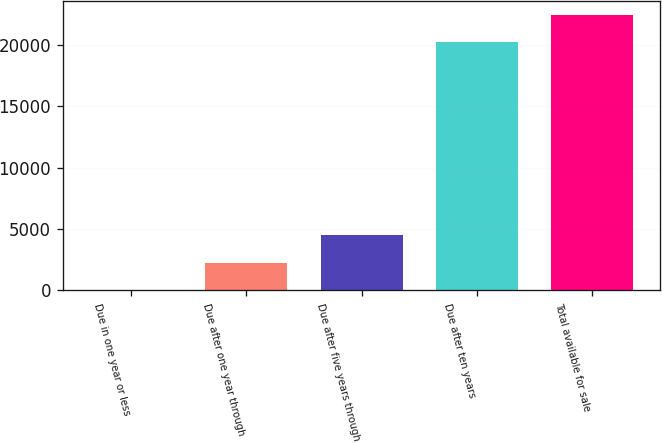Convert chart to OTSL. <chart><loc_0><loc_0><loc_500><loc_500><bar_chart><fcel>Due in one year or less<fcel>Due after one year through<fcel>Due after five years through<fcel>Due after ten years<fcel>Total available for sale<nl><fcel>69<fcel>2277.8<fcel>4486.6<fcel>20264<fcel>22472.8<nl></chart> 